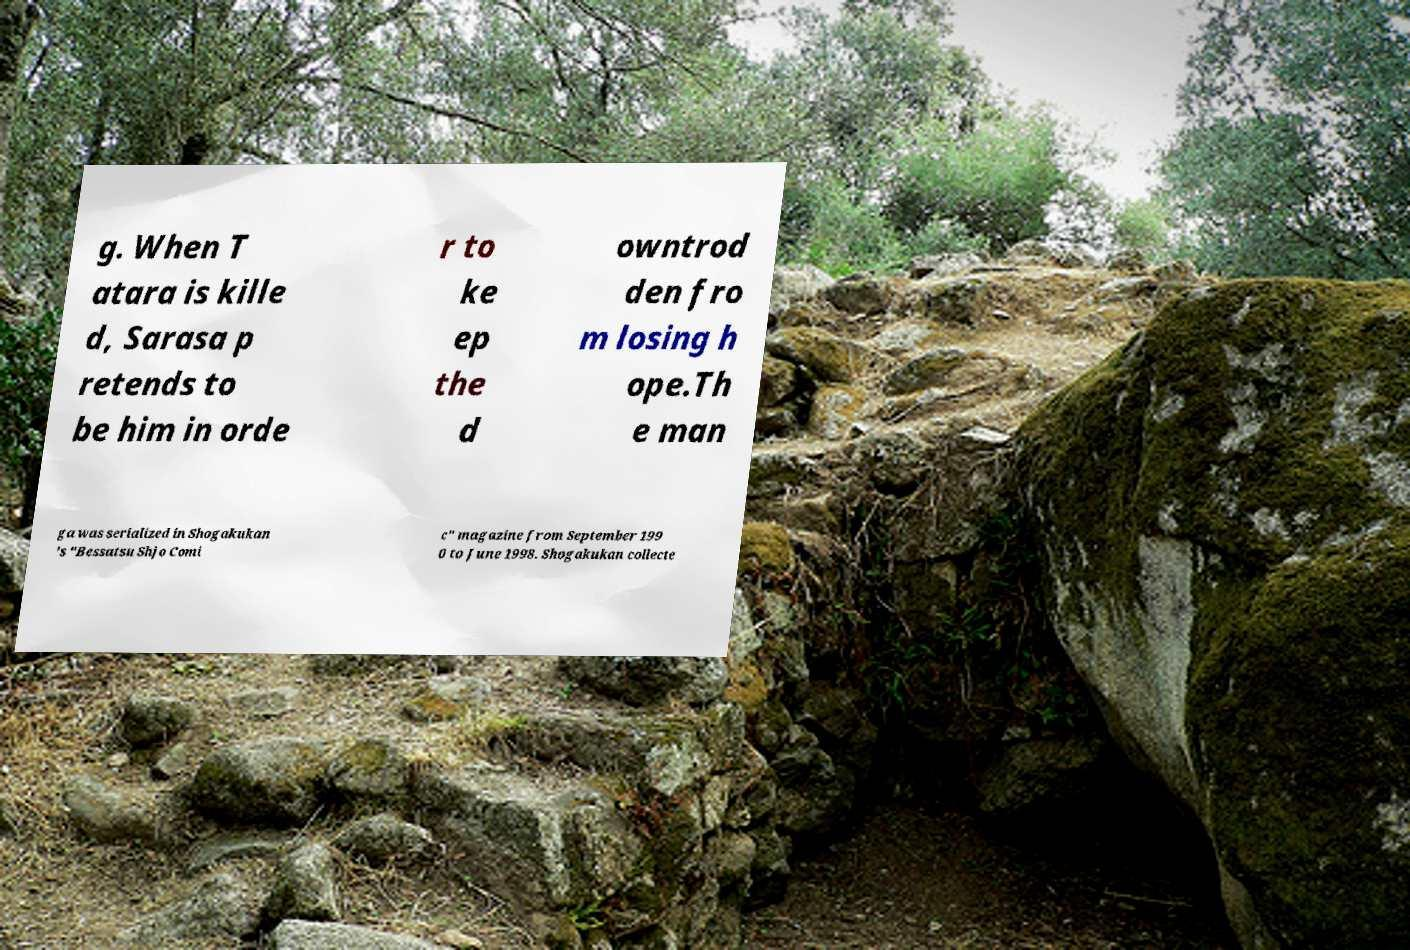Please read and relay the text visible in this image. What does it say? g. When T atara is kille d, Sarasa p retends to be him in orde r to ke ep the d owntrod den fro m losing h ope.Th e man ga was serialized in Shogakukan 's "Bessatsu Shjo Comi c" magazine from September 199 0 to June 1998. Shogakukan collecte 